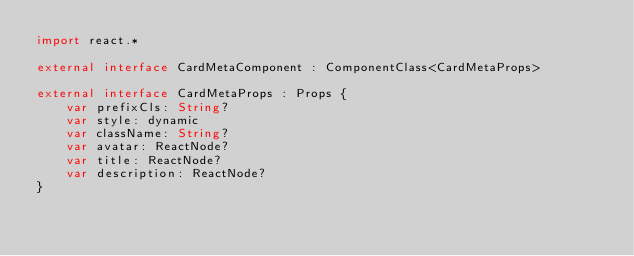Convert code to text. <code><loc_0><loc_0><loc_500><loc_500><_Kotlin_>import react.*

external interface CardMetaComponent : ComponentClass<CardMetaProps>

external interface CardMetaProps : Props {
    var prefixCls: String?
    var style: dynamic
    var className: String?
    var avatar: ReactNode?
    var title: ReactNode?
    var description: ReactNode?
}
</code> 